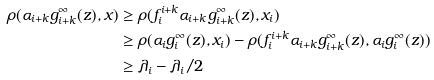<formula> <loc_0><loc_0><loc_500><loc_500>\rho ( \alpha _ { i + k } g ^ { \infty } _ { i + k } ( z ) , x ) & \geq \rho ( f ^ { i + k } _ { i } \alpha _ { i + k } g ^ { \infty } _ { i + k } ( z ) , x _ { i } ) \\ & \geq \rho ( \alpha _ { i } g ^ { \infty } _ { i } ( z ) , x _ { i } ) - \rho ( f ^ { i + k } _ { i } \alpha _ { i + k } g ^ { \infty } _ { i + k } ( z ) , \alpha _ { i } g ^ { \infty } _ { i } ( z ) ) \\ & \geq \lambda _ { i } - \lambda _ { i } / 2</formula> 